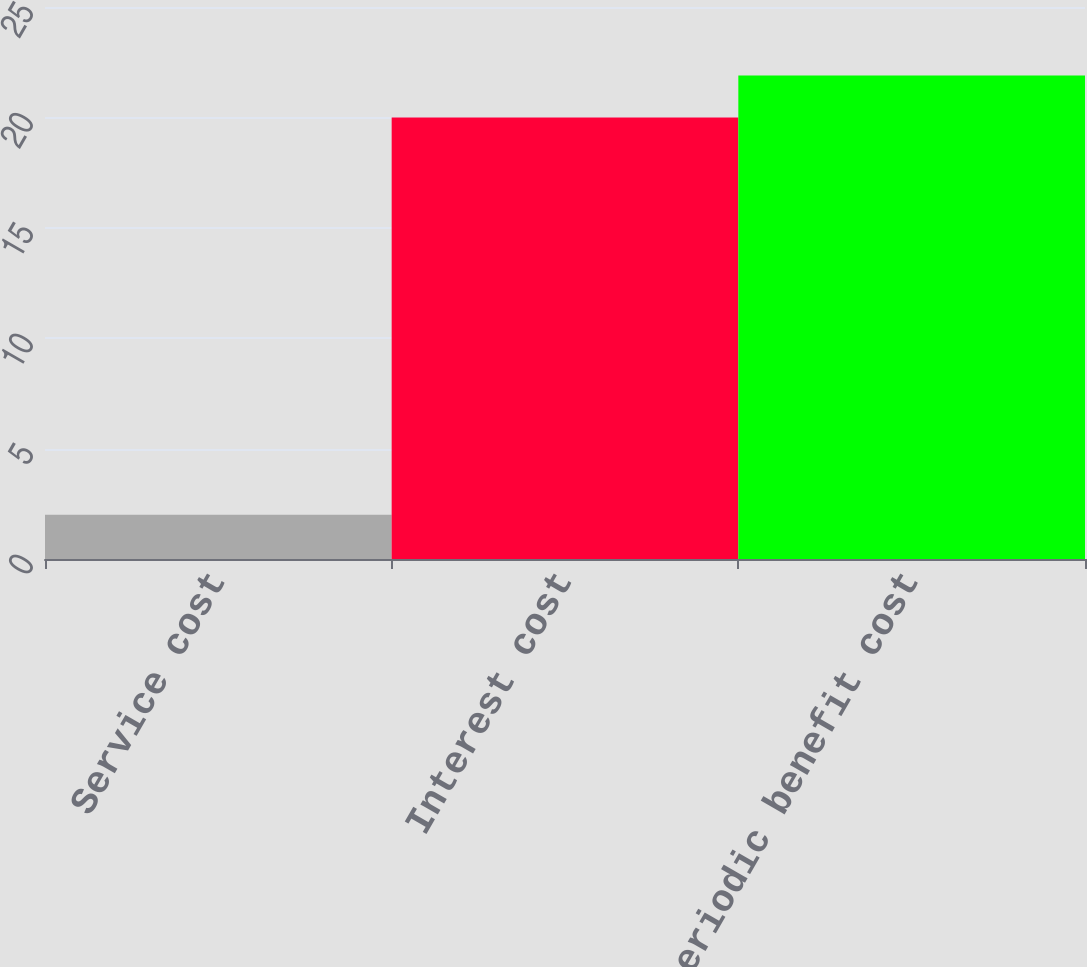Convert chart to OTSL. <chart><loc_0><loc_0><loc_500><loc_500><bar_chart><fcel>Service cost<fcel>Interest cost<fcel>Net periodic benefit cost<nl><fcel>2<fcel>20<fcel>21.9<nl></chart> 